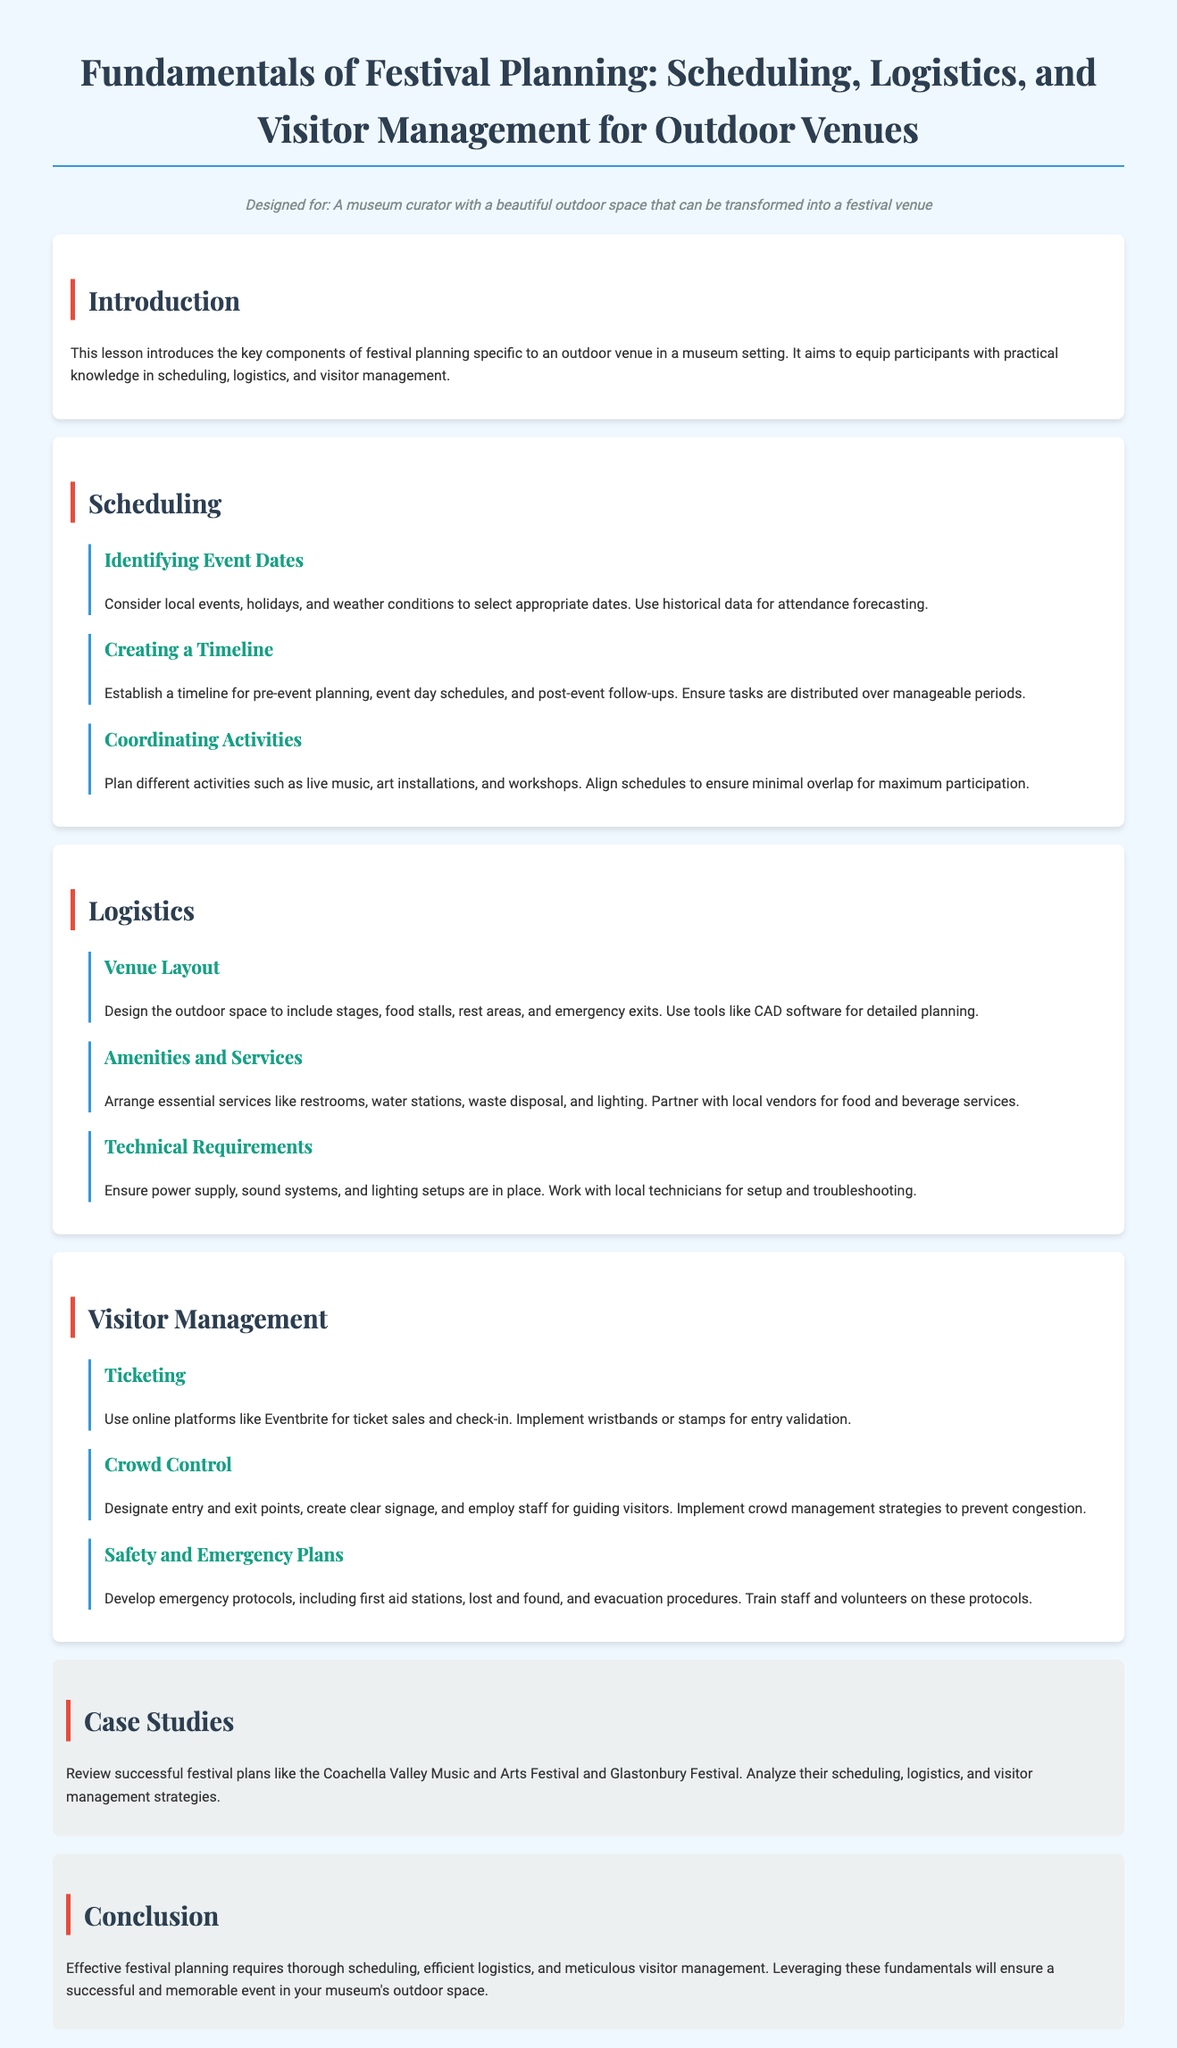What is the purpose of this lesson? The lesson introduces the key components of festival planning specific to an outdoor venue in a museum setting.
Answer: Key components of festival planning What should be considered when identifying event dates? Local events, holidays, and weather conditions should be considered for selecting appropriate dates.
Answer: Local events, holidays, and weather conditions What tools can be used for detailed planning of the venue layout? CAD software can be used for detailed planning of the venue layout.
Answer: CAD software What is one way to manage visitor entry validation? Implement wristbands or stamps for entry validation.
Answer: Wristbands or stamps Which type of safety station should be developed according to the document? First aid stations should be developed as part of the safety protocols.
Answer: First aid stations What is an essential amenity mentioned in the logistics section? Restrooms are mentioned as an essential amenity.
Answer: Restrooms What festival is cited as a case study in the document? The Coachella Valley Music and Arts Festival is cited as a case study.
Answer: Coachella Valley Music and Arts Festival How should staff be utilized during crowd control? Staff should be employed for guiding visitors.
Answer: Guiding visitors What does the conclusion emphasize about festival planning? The conclusion emphasizes the necessity of thorough scheduling, efficient logistics, and meticulous visitor management.
Answer: Thorough scheduling, efficient logistics, and meticulous visitor management 